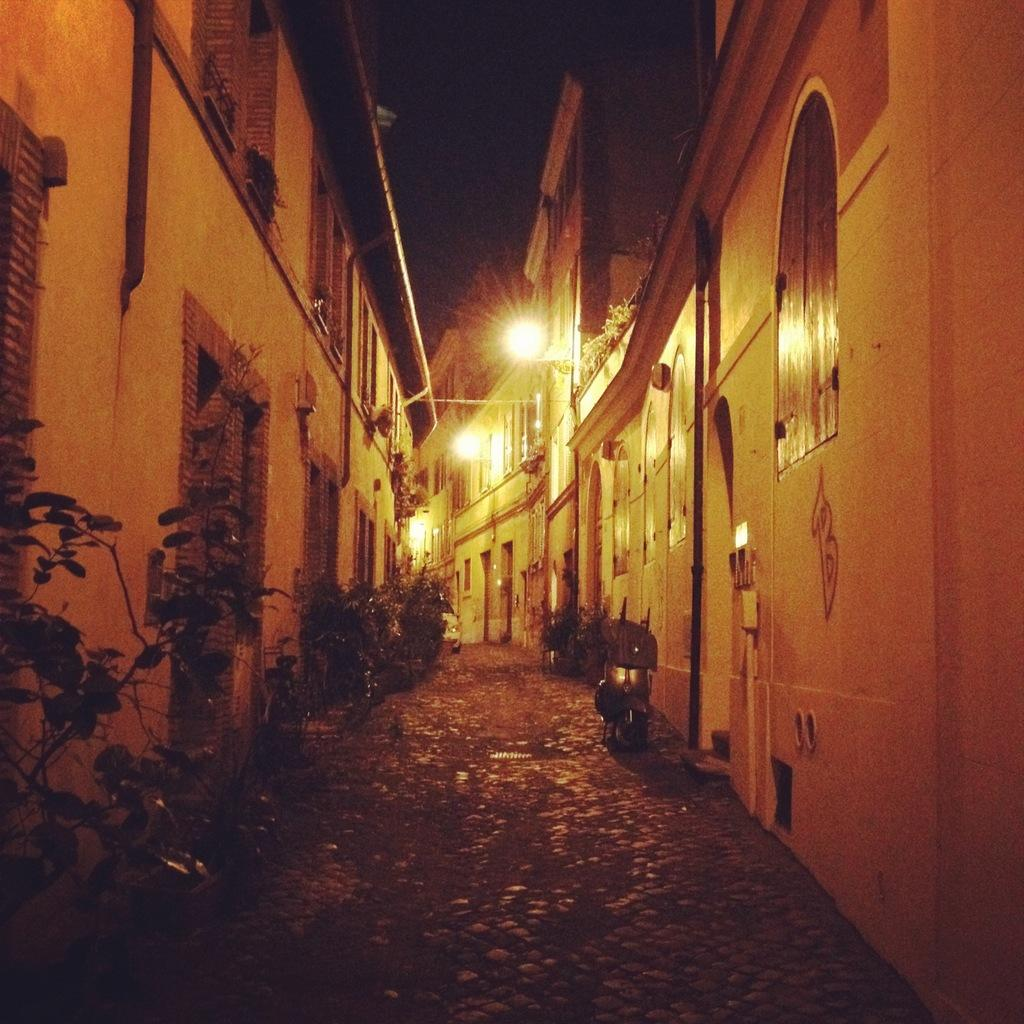What type of structures are present in the image? There are buildings with windows and doors in the image. What else can be seen in the image besides the buildings? There are plants visible in the image, and a motorbike parked in the image. What is the setting of the image? The image appears to be of a street. What can be used for illumination in the image? There are lights in the image. What is the flavor of the furniture in the image? There is no furniture present in the image, so it is not possible to determine its flavor. 